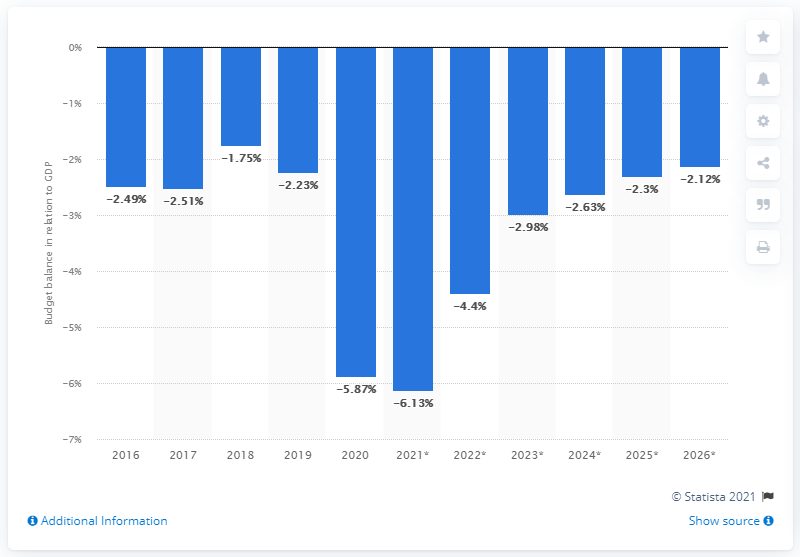Give some essential details in this illustration. In 2020, Indonesia's budget balance came to an end. 